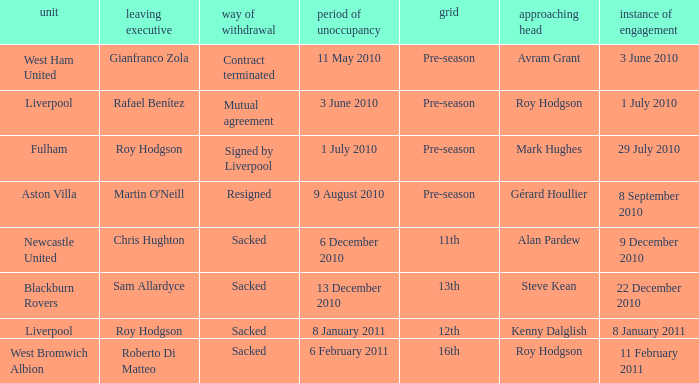What is the date of vacancy for the Liverpool team with a table named pre-season? 3 June 2010. 